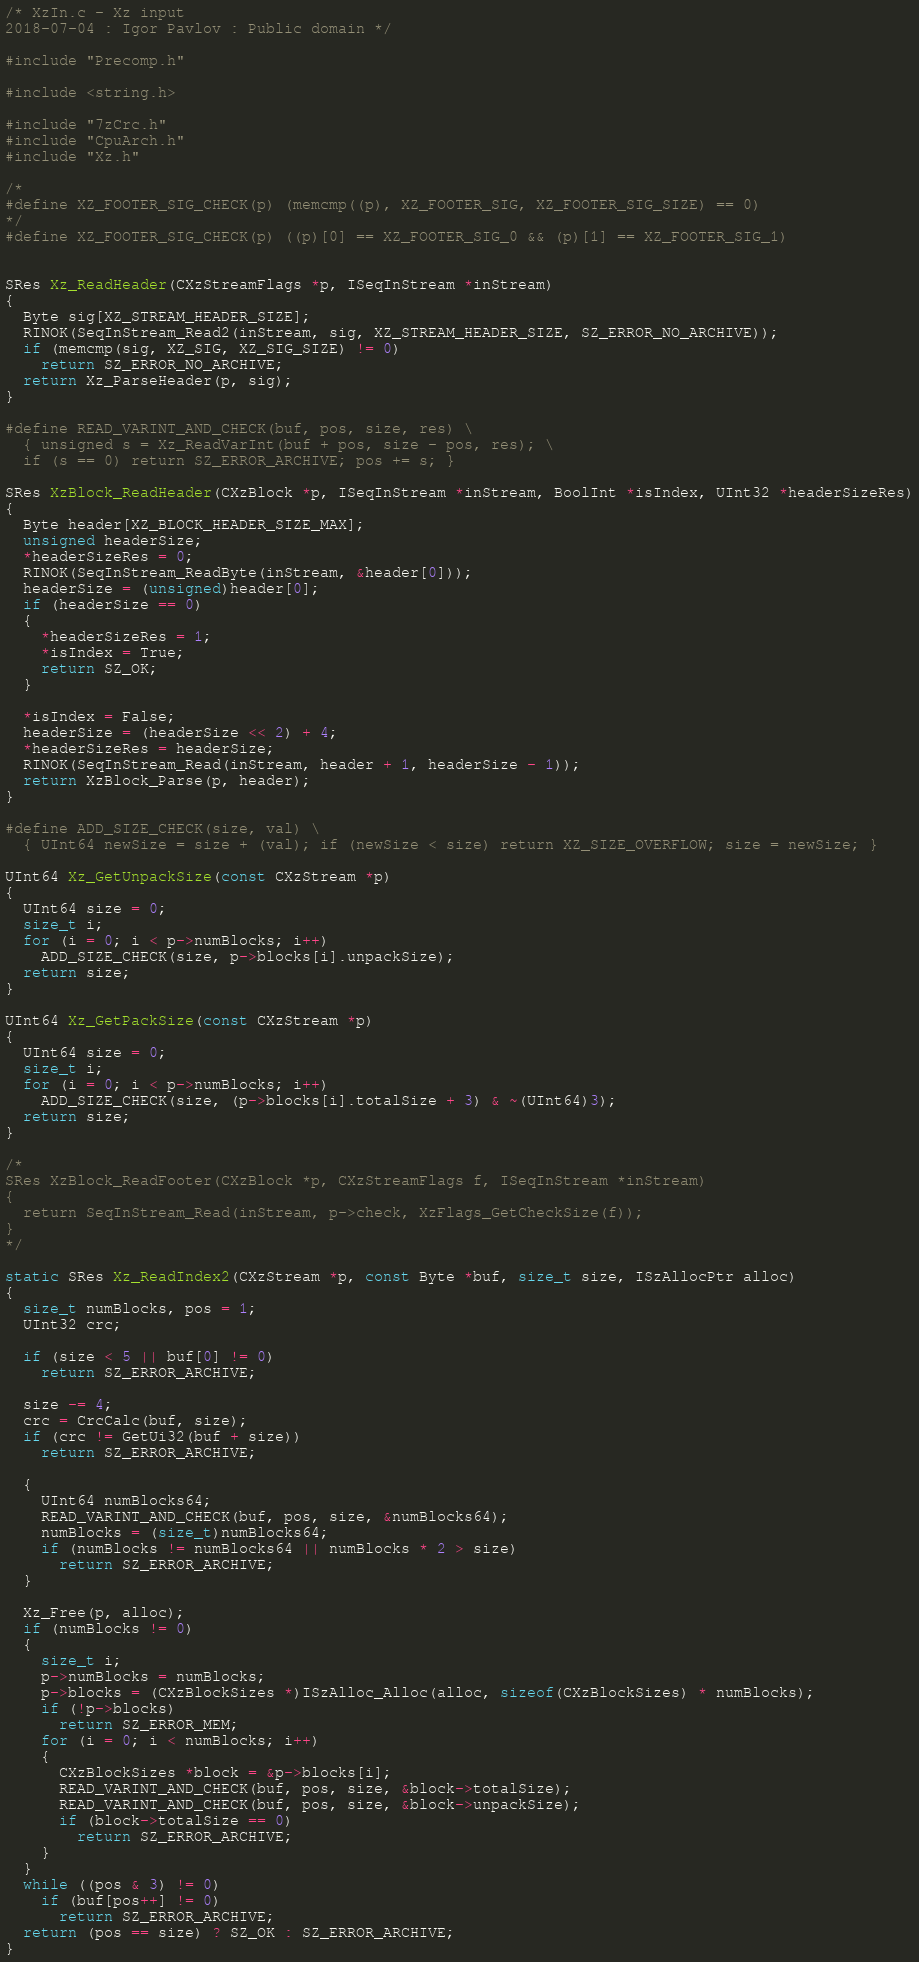<code> <loc_0><loc_0><loc_500><loc_500><_C_>/* XzIn.c - Xz input
2018-07-04 : Igor Pavlov : Public domain */

#include "Precomp.h"

#include <string.h>

#include "7zCrc.h"
#include "CpuArch.h"
#include "Xz.h"

/*
#define XZ_FOOTER_SIG_CHECK(p) (memcmp((p), XZ_FOOTER_SIG, XZ_FOOTER_SIG_SIZE) == 0)
*/
#define XZ_FOOTER_SIG_CHECK(p) ((p)[0] == XZ_FOOTER_SIG_0 && (p)[1] == XZ_FOOTER_SIG_1)


SRes Xz_ReadHeader(CXzStreamFlags *p, ISeqInStream *inStream)
{
  Byte sig[XZ_STREAM_HEADER_SIZE];
  RINOK(SeqInStream_Read2(inStream, sig, XZ_STREAM_HEADER_SIZE, SZ_ERROR_NO_ARCHIVE));
  if (memcmp(sig, XZ_SIG, XZ_SIG_SIZE) != 0)
    return SZ_ERROR_NO_ARCHIVE;
  return Xz_ParseHeader(p, sig);
}

#define READ_VARINT_AND_CHECK(buf, pos, size, res) \
  { unsigned s = Xz_ReadVarInt(buf + pos, size - pos, res); \
  if (s == 0) return SZ_ERROR_ARCHIVE; pos += s; }

SRes XzBlock_ReadHeader(CXzBlock *p, ISeqInStream *inStream, BoolInt *isIndex, UInt32 *headerSizeRes)
{
  Byte header[XZ_BLOCK_HEADER_SIZE_MAX];
  unsigned headerSize;
  *headerSizeRes = 0;
  RINOK(SeqInStream_ReadByte(inStream, &header[0]));
  headerSize = (unsigned)header[0];
  if (headerSize == 0)
  {
    *headerSizeRes = 1;
    *isIndex = True;
    return SZ_OK;
  }

  *isIndex = False;
  headerSize = (headerSize << 2) + 4;
  *headerSizeRes = headerSize;
  RINOK(SeqInStream_Read(inStream, header + 1, headerSize - 1));
  return XzBlock_Parse(p, header);
}

#define ADD_SIZE_CHECK(size, val) \
  { UInt64 newSize = size + (val); if (newSize < size) return XZ_SIZE_OVERFLOW; size = newSize; }

UInt64 Xz_GetUnpackSize(const CXzStream *p)
{
  UInt64 size = 0;
  size_t i;
  for (i = 0; i < p->numBlocks; i++)
    ADD_SIZE_CHECK(size, p->blocks[i].unpackSize);
  return size;
}

UInt64 Xz_GetPackSize(const CXzStream *p)
{
  UInt64 size = 0;
  size_t i;
  for (i = 0; i < p->numBlocks; i++)
    ADD_SIZE_CHECK(size, (p->blocks[i].totalSize + 3) & ~(UInt64)3);
  return size;
}

/*
SRes XzBlock_ReadFooter(CXzBlock *p, CXzStreamFlags f, ISeqInStream *inStream)
{
  return SeqInStream_Read(inStream, p->check, XzFlags_GetCheckSize(f));
}
*/

static SRes Xz_ReadIndex2(CXzStream *p, const Byte *buf, size_t size, ISzAllocPtr alloc)
{
  size_t numBlocks, pos = 1;
  UInt32 crc;

  if (size < 5 || buf[0] != 0)
    return SZ_ERROR_ARCHIVE;

  size -= 4;
  crc = CrcCalc(buf, size);
  if (crc != GetUi32(buf + size))
    return SZ_ERROR_ARCHIVE;

  {
    UInt64 numBlocks64;
    READ_VARINT_AND_CHECK(buf, pos, size, &numBlocks64);
    numBlocks = (size_t)numBlocks64;
    if (numBlocks != numBlocks64 || numBlocks * 2 > size)
      return SZ_ERROR_ARCHIVE;
  }
  
  Xz_Free(p, alloc);
  if (numBlocks != 0)
  {
    size_t i;
    p->numBlocks = numBlocks;
    p->blocks = (CXzBlockSizes *)ISzAlloc_Alloc(alloc, sizeof(CXzBlockSizes) * numBlocks);
    if (!p->blocks)
      return SZ_ERROR_MEM;
    for (i = 0; i < numBlocks; i++)
    {
      CXzBlockSizes *block = &p->blocks[i];
      READ_VARINT_AND_CHECK(buf, pos, size, &block->totalSize);
      READ_VARINT_AND_CHECK(buf, pos, size, &block->unpackSize);
      if (block->totalSize == 0)
        return SZ_ERROR_ARCHIVE;
    }
  }
  while ((pos & 3) != 0)
    if (buf[pos++] != 0)
      return SZ_ERROR_ARCHIVE;
  return (pos == size) ? SZ_OK : SZ_ERROR_ARCHIVE;
}
</code> 